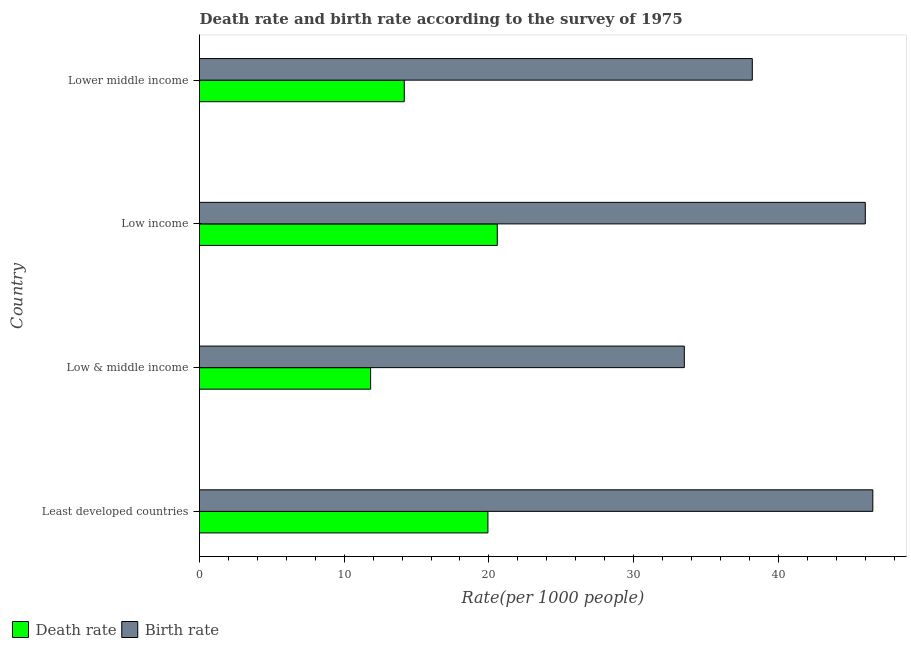How many groups of bars are there?
Give a very brief answer. 4. Are the number of bars on each tick of the Y-axis equal?
Give a very brief answer. Yes. How many bars are there on the 1st tick from the top?
Your answer should be very brief. 2. How many bars are there on the 3rd tick from the bottom?
Provide a short and direct response. 2. What is the label of the 1st group of bars from the top?
Your answer should be compact. Lower middle income. What is the death rate in Low & middle income?
Your answer should be compact. 11.82. Across all countries, what is the maximum death rate?
Your response must be concise. 20.58. Across all countries, what is the minimum death rate?
Offer a terse response. 11.82. In which country was the birth rate maximum?
Provide a short and direct response. Least developed countries. In which country was the birth rate minimum?
Offer a very short reply. Low & middle income. What is the total birth rate in the graph?
Ensure brevity in your answer.  164.25. What is the difference between the death rate in Least developed countries and that in Low & middle income?
Provide a short and direct response. 8.11. What is the difference between the birth rate in Low & middle income and the death rate in Low income?
Offer a very short reply. 12.93. What is the average birth rate per country?
Provide a succinct answer. 41.06. What is the difference between the death rate and birth rate in Low & middle income?
Your response must be concise. -21.68. What is the ratio of the death rate in Low & middle income to that in Lower middle income?
Keep it short and to the point. 0.84. Is the difference between the death rate in Low income and Lower middle income greater than the difference between the birth rate in Low income and Lower middle income?
Give a very brief answer. No. What is the difference between the highest and the second highest birth rate?
Keep it short and to the point. 0.52. What is the difference between the highest and the lowest death rate?
Provide a short and direct response. 8.75. In how many countries, is the birth rate greater than the average birth rate taken over all countries?
Your answer should be compact. 2. What does the 2nd bar from the top in Least developed countries represents?
Give a very brief answer. Death rate. What does the 2nd bar from the bottom in Low income represents?
Give a very brief answer. Birth rate. How many bars are there?
Keep it short and to the point. 8. How many countries are there in the graph?
Offer a terse response. 4. How are the legend labels stacked?
Provide a succinct answer. Horizontal. What is the title of the graph?
Your response must be concise. Death rate and birth rate according to the survey of 1975. What is the label or title of the X-axis?
Make the answer very short. Rate(per 1000 people). What is the Rate(per 1000 people) of Death rate in Least developed countries?
Your response must be concise. 19.93. What is the Rate(per 1000 people) in Birth rate in Least developed countries?
Provide a succinct answer. 46.53. What is the Rate(per 1000 people) in Death rate in Low & middle income?
Your answer should be compact. 11.82. What is the Rate(per 1000 people) in Birth rate in Low & middle income?
Give a very brief answer. 33.5. What is the Rate(per 1000 people) of Death rate in Low income?
Provide a succinct answer. 20.58. What is the Rate(per 1000 people) of Birth rate in Low income?
Give a very brief answer. 46.01. What is the Rate(per 1000 people) in Death rate in Lower middle income?
Give a very brief answer. 14.15. What is the Rate(per 1000 people) of Birth rate in Lower middle income?
Ensure brevity in your answer.  38.2. Across all countries, what is the maximum Rate(per 1000 people) of Death rate?
Ensure brevity in your answer.  20.58. Across all countries, what is the maximum Rate(per 1000 people) of Birth rate?
Provide a short and direct response. 46.53. Across all countries, what is the minimum Rate(per 1000 people) of Death rate?
Ensure brevity in your answer.  11.82. Across all countries, what is the minimum Rate(per 1000 people) of Birth rate?
Keep it short and to the point. 33.5. What is the total Rate(per 1000 people) of Death rate in the graph?
Provide a succinct answer. 66.49. What is the total Rate(per 1000 people) in Birth rate in the graph?
Your answer should be compact. 164.25. What is the difference between the Rate(per 1000 people) of Death rate in Least developed countries and that in Low & middle income?
Make the answer very short. 8.11. What is the difference between the Rate(per 1000 people) of Birth rate in Least developed countries and that in Low & middle income?
Ensure brevity in your answer.  13.03. What is the difference between the Rate(per 1000 people) in Death rate in Least developed countries and that in Low income?
Provide a succinct answer. -0.65. What is the difference between the Rate(per 1000 people) in Birth rate in Least developed countries and that in Low income?
Your answer should be very brief. 0.52. What is the difference between the Rate(per 1000 people) in Death rate in Least developed countries and that in Lower middle income?
Ensure brevity in your answer.  5.78. What is the difference between the Rate(per 1000 people) of Birth rate in Least developed countries and that in Lower middle income?
Offer a very short reply. 8.33. What is the difference between the Rate(per 1000 people) in Death rate in Low & middle income and that in Low income?
Your answer should be compact. -8.75. What is the difference between the Rate(per 1000 people) in Birth rate in Low & middle income and that in Low income?
Your answer should be compact. -12.51. What is the difference between the Rate(per 1000 people) in Death rate in Low & middle income and that in Lower middle income?
Your answer should be very brief. -2.33. What is the difference between the Rate(per 1000 people) in Birth rate in Low & middle income and that in Lower middle income?
Your response must be concise. -4.7. What is the difference between the Rate(per 1000 people) of Death rate in Low income and that in Lower middle income?
Make the answer very short. 6.43. What is the difference between the Rate(per 1000 people) of Birth rate in Low income and that in Lower middle income?
Your answer should be compact. 7.81. What is the difference between the Rate(per 1000 people) in Death rate in Least developed countries and the Rate(per 1000 people) in Birth rate in Low & middle income?
Your answer should be very brief. -13.57. What is the difference between the Rate(per 1000 people) of Death rate in Least developed countries and the Rate(per 1000 people) of Birth rate in Low income?
Your answer should be compact. -26.08. What is the difference between the Rate(per 1000 people) of Death rate in Least developed countries and the Rate(per 1000 people) of Birth rate in Lower middle income?
Your answer should be very brief. -18.27. What is the difference between the Rate(per 1000 people) in Death rate in Low & middle income and the Rate(per 1000 people) in Birth rate in Low income?
Your answer should be compact. -34.19. What is the difference between the Rate(per 1000 people) of Death rate in Low & middle income and the Rate(per 1000 people) of Birth rate in Lower middle income?
Make the answer very short. -26.38. What is the difference between the Rate(per 1000 people) of Death rate in Low income and the Rate(per 1000 people) of Birth rate in Lower middle income?
Your answer should be very brief. -17.62. What is the average Rate(per 1000 people) of Death rate per country?
Provide a short and direct response. 16.62. What is the average Rate(per 1000 people) in Birth rate per country?
Give a very brief answer. 41.06. What is the difference between the Rate(per 1000 people) in Death rate and Rate(per 1000 people) in Birth rate in Least developed countries?
Give a very brief answer. -26.6. What is the difference between the Rate(per 1000 people) in Death rate and Rate(per 1000 people) in Birth rate in Low & middle income?
Offer a terse response. -21.68. What is the difference between the Rate(per 1000 people) in Death rate and Rate(per 1000 people) in Birth rate in Low income?
Keep it short and to the point. -25.43. What is the difference between the Rate(per 1000 people) of Death rate and Rate(per 1000 people) of Birth rate in Lower middle income?
Give a very brief answer. -24.05. What is the ratio of the Rate(per 1000 people) of Death rate in Least developed countries to that in Low & middle income?
Provide a succinct answer. 1.69. What is the ratio of the Rate(per 1000 people) in Birth rate in Least developed countries to that in Low & middle income?
Provide a short and direct response. 1.39. What is the ratio of the Rate(per 1000 people) of Death rate in Least developed countries to that in Low income?
Keep it short and to the point. 0.97. What is the ratio of the Rate(per 1000 people) of Birth rate in Least developed countries to that in Low income?
Provide a succinct answer. 1.01. What is the ratio of the Rate(per 1000 people) of Death rate in Least developed countries to that in Lower middle income?
Ensure brevity in your answer.  1.41. What is the ratio of the Rate(per 1000 people) in Birth rate in Least developed countries to that in Lower middle income?
Your response must be concise. 1.22. What is the ratio of the Rate(per 1000 people) in Death rate in Low & middle income to that in Low income?
Your answer should be very brief. 0.57. What is the ratio of the Rate(per 1000 people) of Birth rate in Low & middle income to that in Low income?
Offer a terse response. 0.73. What is the ratio of the Rate(per 1000 people) in Death rate in Low & middle income to that in Lower middle income?
Ensure brevity in your answer.  0.84. What is the ratio of the Rate(per 1000 people) in Birth rate in Low & middle income to that in Lower middle income?
Offer a very short reply. 0.88. What is the ratio of the Rate(per 1000 people) of Death rate in Low income to that in Lower middle income?
Your response must be concise. 1.45. What is the ratio of the Rate(per 1000 people) in Birth rate in Low income to that in Lower middle income?
Provide a succinct answer. 1.2. What is the difference between the highest and the second highest Rate(per 1000 people) of Death rate?
Make the answer very short. 0.65. What is the difference between the highest and the second highest Rate(per 1000 people) of Birth rate?
Offer a very short reply. 0.52. What is the difference between the highest and the lowest Rate(per 1000 people) of Death rate?
Your response must be concise. 8.75. What is the difference between the highest and the lowest Rate(per 1000 people) in Birth rate?
Ensure brevity in your answer.  13.03. 